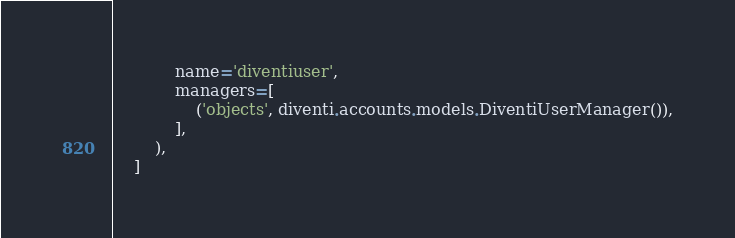Convert code to text. <code><loc_0><loc_0><loc_500><loc_500><_Python_>            name='diventiuser',
            managers=[
                ('objects', diventi.accounts.models.DiventiUserManager()),
            ],
        ),
    ]
</code> 